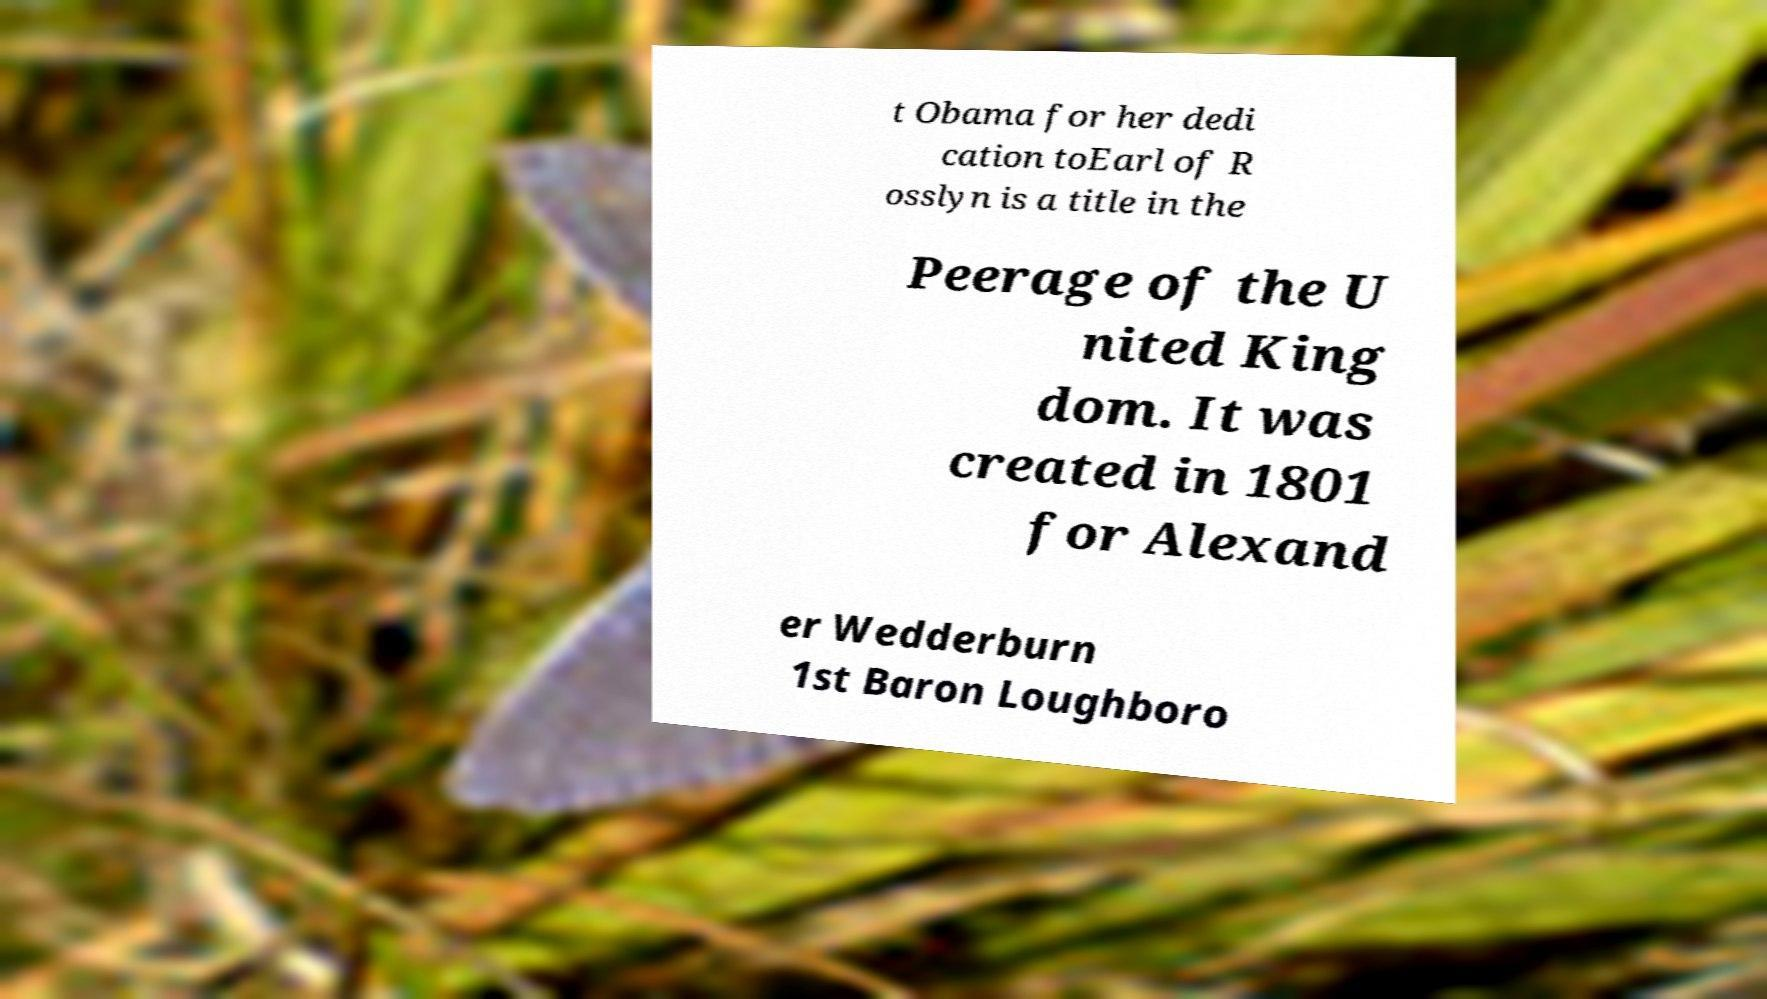There's text embedded in this image that I need extracted. Can you transcribe it verbatim? t Obama for her dedi cation toEarl of R osslyn is a title in the Peerage of the U nited King dom. It was created in 1801 for Alexand er Wedderburn 1st Baron Loughboro 